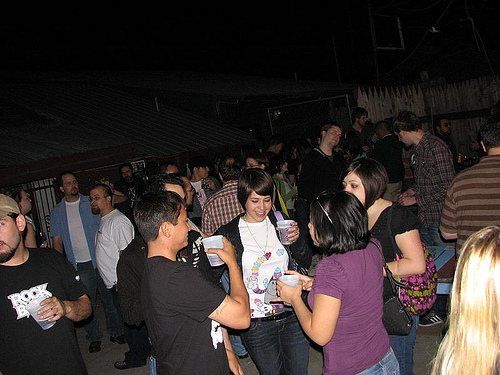<image>
Can you confirm if the men is next to the women? Yes. The men is positioned adjacent to the women, located nearby in the same general area. 